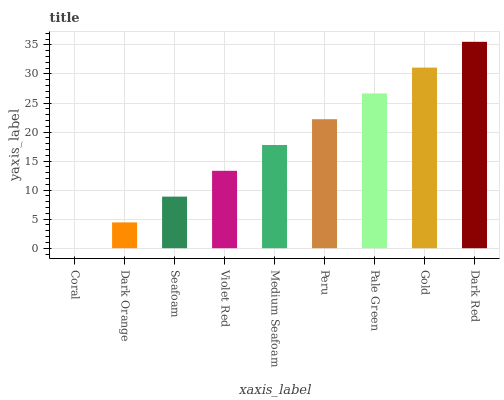Is Coral the minimum?
Answer yes or no. Yes. Is Dark Red the maximum?
Answer yes or no. Yes. Is Dark Orange the minimum?
Answer yes or no. No. Is Dark Orange the maximum?
Answer yes or no. No. Is Dark Orange greater than Coral?
Answer yes or no. Yes. Is Coral less than Dark Orange?
Answer yes or no. Yes. Is Coral greater than Dark Orange?
Answer yes or no. No. Is Dark Orange less than Coral?
Answer yes or no. No. Is Medium Seafoam the high median?
Answer yes or no. Yes. Is Medium Seafoam the low median?
Answer yes or no. Yes. Is Violet Red the high median?
Answer yes or no. No. Is Gold the low median?
Answer yes or no. No. 